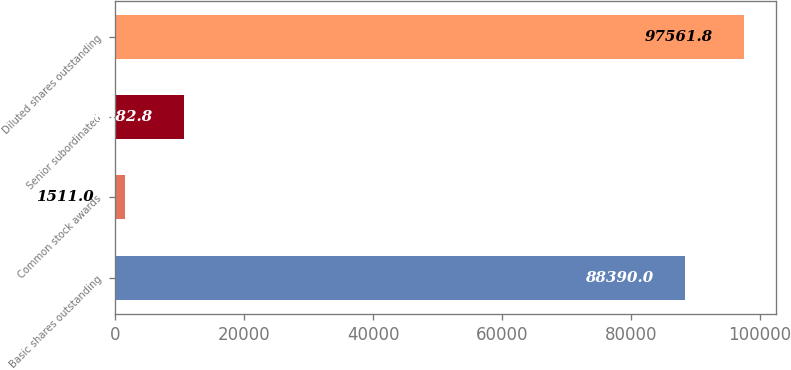Convert chart. <chart><loc_0><loc_0><loc_500><loc_500><bar_chart><fcel>Basic shares outstanding<fcel>Common stock awards<fcel>Senior subordinated<fcel>Diluted shares outstanding<nl><fcel>88390<fcel>1511<fcel>10682.8<fcel>97561.8<nl></chart> 